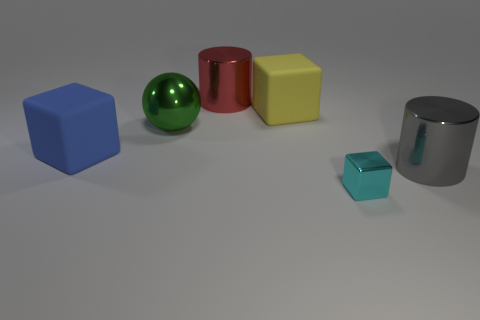Subtract all blue blocks. How many blocks are left? 2 Subtract all rubber blocks. How many blocks are left? 1 Subtract 2 blocks. How many blocks are left? 1 Add 4 yellow matte blocks. How many objects exist? 10 Subtract all cylinders. How many objects are left? 4 Subtract all gray cylinders. Subtract all red spheres. How many cylinders are left? 1 Subtract all red spheres. How many purple cubes are left? 0 Subtract all blue objects. Subtract all big cylinders. How many objects are left? 3 Add 1 metal cylinders. How many metal cylinders are left? 3 Add 5 big blue matte things. How many big blue matte things exist? 6 